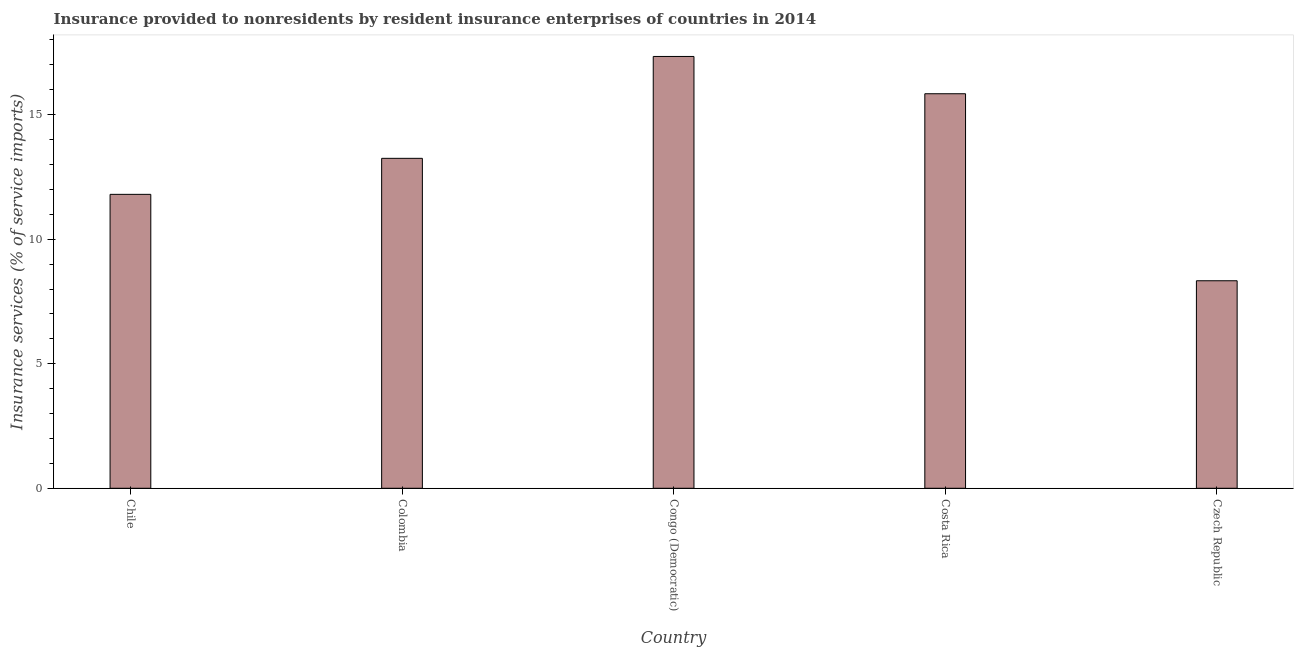Does the graph contain any zero values?
Keep it short and to the point. No. Does the graph contain grids?
Keep it short and to the point. No. What is the title of the graph?
Make the answer very short. Insurance provided to nonresidents by resident insurance enterprises of countries in 2014. What is the label or title of the Y-axis?
Provide a succinct answer. Insurance services (% of service imports). What is the insurance and financial services in Costa Rica?
Provide a succinct answer. 15.84. Across all countries, what is the maximum insurance and financial services?
Offer a very short reply. 17.34. Across all countries, what is the minimum insurance and financial services?
Keep it short and to the point. 8.33. In which country was the insurance and financial services maximum?
Provide a short and direct response. Congo (Democratic). In which country was the insurance and financial services minimum?
Your response must be concise. Czech Republic. What is the sum of the insurance and financial services?
Offer a terse response. 66.56. What is the difference between the insurance and financial services in Costa Rica and Czech Republic?
Ensure brevity in your answer.  7.51. What is the average insurance and financial services per country?
Your answer should be compact. 13.31. What is the median insurance and financial services?
Keep it short and to the point. 13.25. In how many countries, is the insurance and financial services greater than 5 %?
Your answer should be very brief. 5. What is the ratio of the insurance and financial services in Colombia to that in Congo (Democratic)?
Your answer should be compact. 0.76. What is the difference between the highest and the second highest insurance and financial services?
Provide a succinct answer. 1.5. What is the difference between the highest and the lowest insurance and financial services?
Your answer should be compact. 9.01. In how many countries, is the insurance and financial services greater than the average insurance and financial services taken over all countries?
Provide a succinct answer. 2. How many bars are there?
Your answer should be very brief. 5. Are all the bars in the graph horizontal?
Ensure brevity in your answer.  No. How many countries are there in the graph?
Keep it short and to the point. 5. What is the difference between two consecutive major ticks on the Y-axis?
Ensure brevity in your answer.  5. Are the values on the major ticks of Y-axis written in scientific E-notation?
Ensure brevity in your answer.  No. What is the Insurance services (% of service imports) of Chile?
Ensure brevity in your answer.  11.8. What is the Insurance services (% of service imports) of Colombia?
Your answer should be compact. 13.25. What is the Insurance services (% of service imports) of Congo (Democratic)?
Your answer should be compact. 17.34. What is the Insurance services (% of service imports) in Costa Rica?
Your answer should be compact. 15.84. What is the Insurance services (% of service imports) in Czech Republic?
Your answer should be compact. 8.33. What is the difference between the Insurance services (% of service imports) in Chile and Colombia?
Give a very brief answer. -1.45. What is the difference between the Insurance services (% of service imports) in Chile and Congo (Democratic)?
Your response must be concise. -5.54. What is the difference between the Insurance services (% of service imports) in Chile and Costa Rica?
Make the answer very short. -4.04. What is the difference between the Insurance services (% of service imports) in Chile and Czech Republic?
Make the answer very short. 3.47. What is the difference between the Insurance services (% of service imports) in Colombia and Congo (Democratic)?
Offer a terse response. -4.09. What is the difference between the Insurance services (% of service imports) in Colombia and Costa Rica?
Ensure brevity in your answer.  -2.59. What is the difference between the Insurance services (% of service imports) in Colombia and Czech Republic?
Offer a very short reply. 4.92. What is the difference between the Insurance services (% of service imports) in Congo (Democratic) and Costa Rica?
Make the answer very short. 1.5. What is the difference between the Insurance services (% of service imports) in Congo (Democratic) and Czech Republic?
Your answer should be very brief. 9.01. What is the difference between the Insurance services (% of service imports) in Costa Rica and Czech Republic?
Offer a terse response. 7.51. What is the ratio of the Insurance services (% of service imports) in Chile to that in Colombia?
Offer a very short reply. 0.89. What is the ratio of the Insurance services (% of service imports) in Chile to that in Congo (Democratic)?
Keep it short and to the point. 0.68. What is the ratio of the Insurance services (% of service imports) in Chile to that in Costa Rica?
Provide a succinct answer. 0.74. What is the ratio of the Insurance services (% of service imports) in Chile to that in Czech Republic?
Your answer should be very brief. 1.42. What is the ratio of the Insurance services (% of service imports) in Colombia to that in Congo (Democratic)?
Your answer should be compact. 0.76. What is the ratio of the Insurance services (% of service imports) in Colombia to that in Costa Rica?
Give a very brief answer. 0.84. What is the ratio of the Insurance services (% of service imports) in Colombia to that in Czech Republic?
Make the answer very short. 1.59. What is the ratio of the Insurance services (% of service imports) in Congo (Democratic) to that in Costa Rica?
Provide a short and direct response. 1.09. What is the ratio of the Insurance services (% of service imports) in Congo (Democratic) to that in Czech Republic?
Your answer should be very brief. 2.08. What is the ratio of the Insurance services (% of service imports) in Costa Rica to that in Czech Republic?
Your answer should be compact. 1.9. 